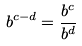Convert formula to latex. <formula><loc_0><loc_0><loc_500><loc_500>b ^ { c - d } = \frac { b ^ { c } } { b ^ { d } }</formula> 